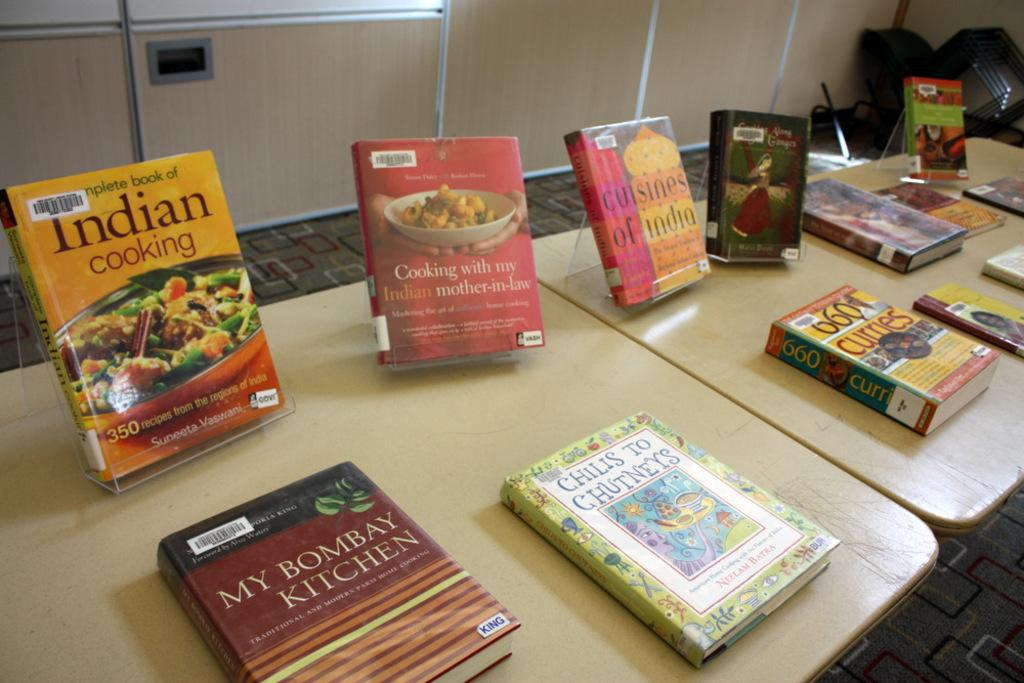Provide a one-sentence caption for the provided image. A series of cooking books such as My Bombay Kitchen and Indian Cooking sitting on a table. 